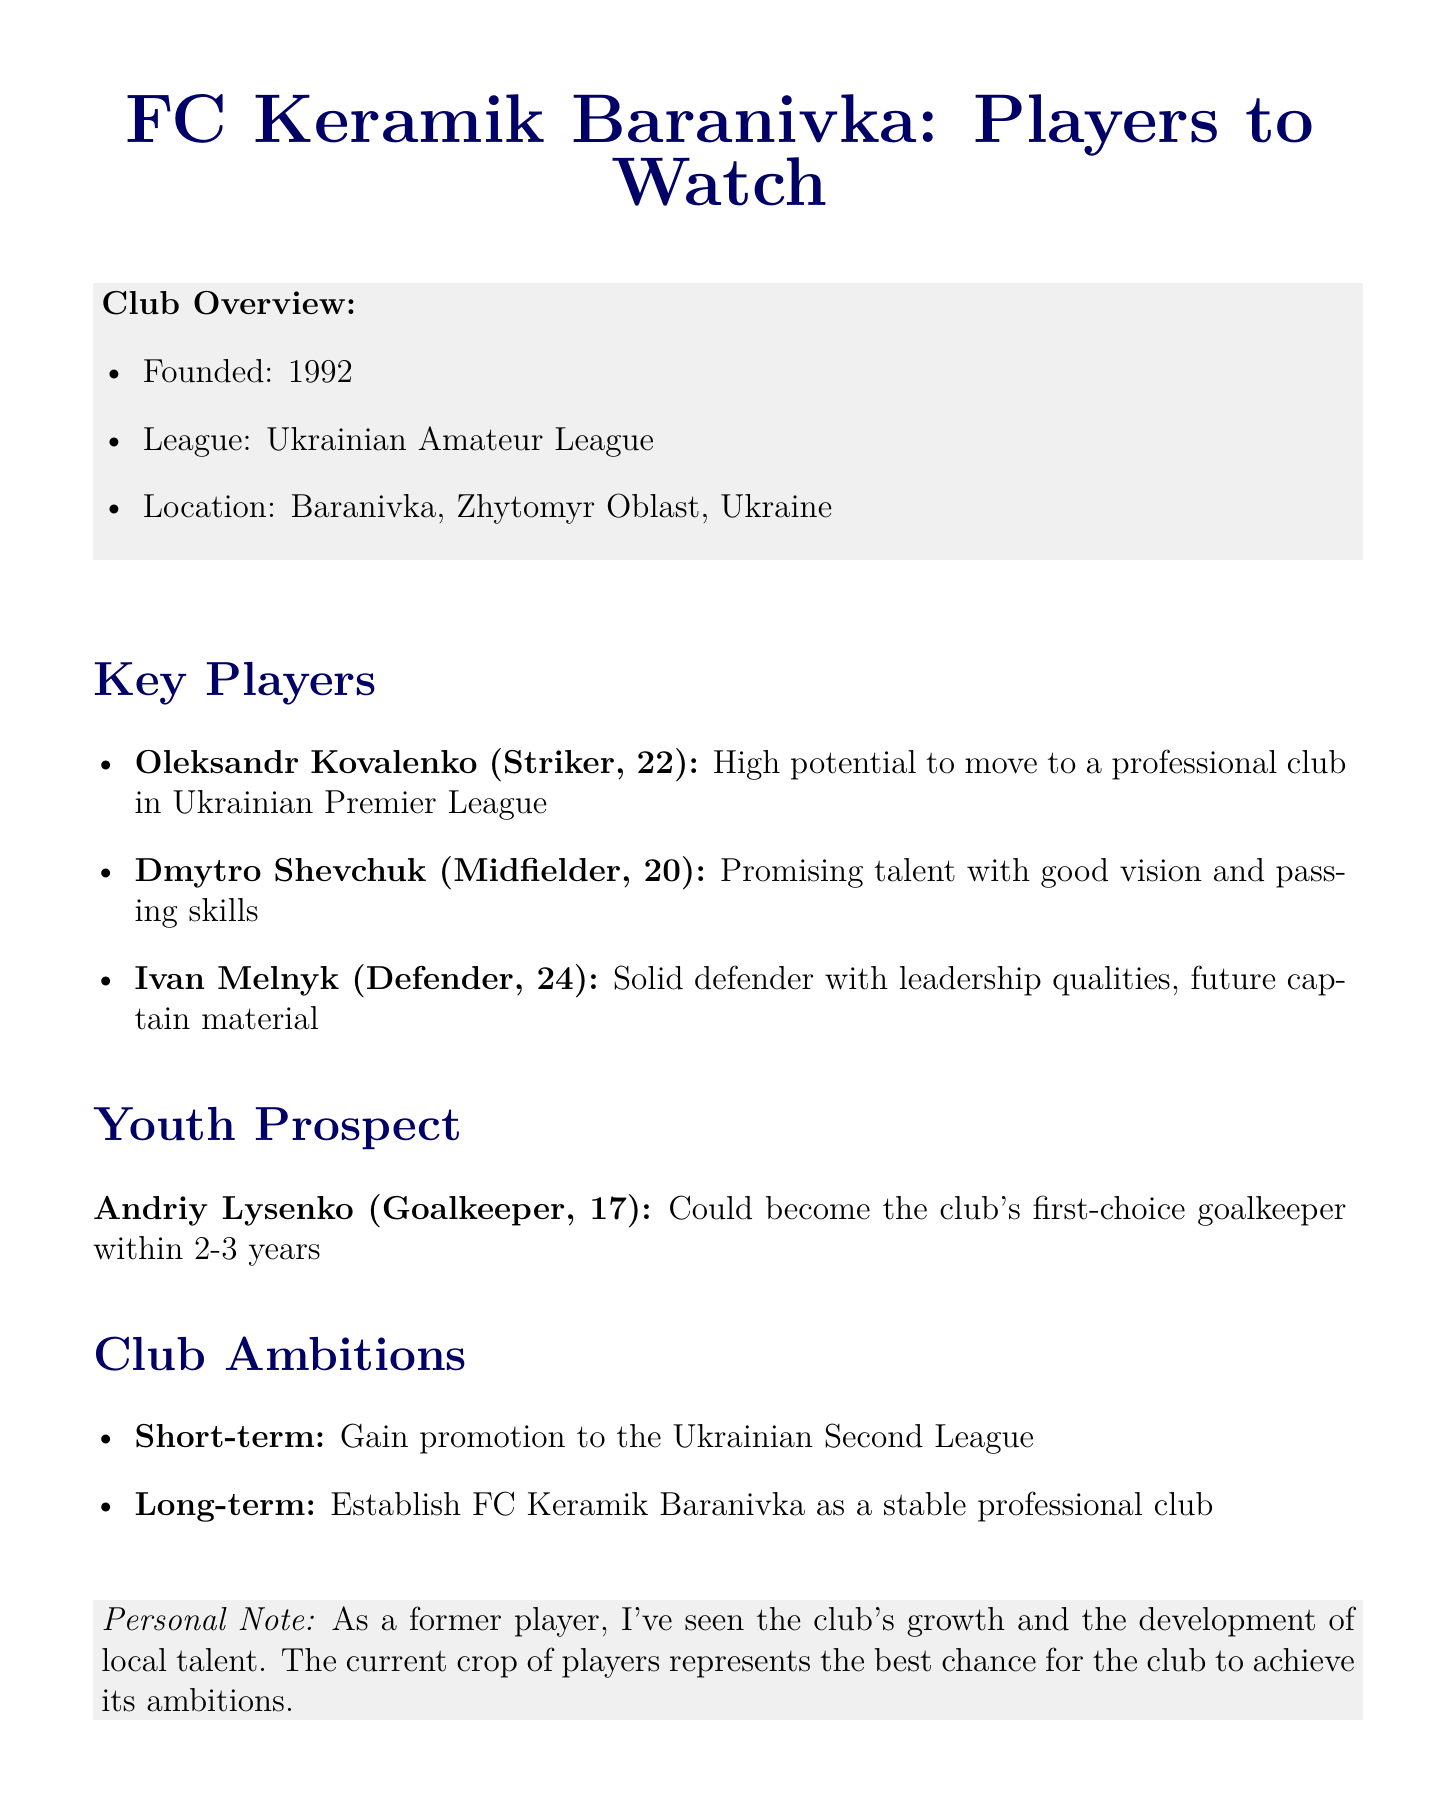What year was FC Keramik Baranivka founded? The founding year of FC Keramik Baranivka is mentioned in the club overview section.
Answer: 1992 Who is the top prospect in the youth academy? The youth academy section specifically highlights the top prospect's name.
Answer: Andriy Lysenko What position does Oleksandr Kovalenko play? Oleksandr Kovalenko's position is stated directly in the key players section.
Answer: Striker How old is Dmytro Shevchuk? Dmytro Shevchuk's age is provided alongside his name in the key players section.
Answer: 20 What is the club's short-term ambition? The short-term ambition is listed explicitly under the club ambitions section.
Answer: Gain promotion to the Ukrainian Second League What potential does Ivan Melnyk have? Ivan Melnyk's potential is described in the key players section.
Answer: Future captain material In what league does FC Keramik Baranivka compete? The league in which the club competes is identified in the club overview section.
Answer: Ukrainian Amateur League What is Andriy Lysenko's position? Andriy Lysenko's position is mentioned in the youth prospect section.
Answer: Goalkeeper What age range do the key players generally fall into? The ages of the key players provide insight into the typical age range, noted in the key players section.
Answer: 20 to 24 